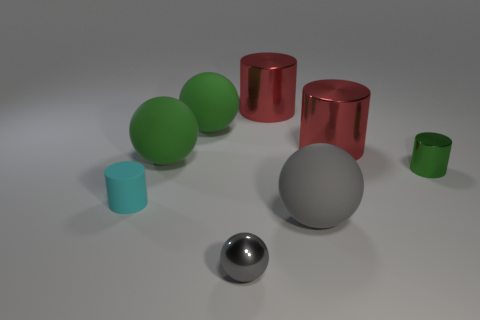How many tiny gray shiny spheres are there?
Your answer should be very brief. 1. How many metallic objects are behind the matte cylinder and in front of the large gray rubber thing?
Your answer should be very brief. 0. What material is the small cyan thing?
Provide a short and direct response. Rubber. Are there any small rubber objects?
Offer a very short reply. Yes. What color is the tiny cylinder behind the matte cylinder?
Keep it short and to the point. Green. What number of big spheres are in front of the tiny thing that is right of the shiny object in front of the big gray object?
Provide a short and direct response. 1. There is a thing that is to the left of the shiny sphere and in front of the small green metal object; what material is it?
Offer a terse response. Rubber. Do the cyan thing and the small green cylinder on the right side of the cyan matte object have the same material?
Ensure brevity in your answer.  No. Are there more red cylinders that are left of the cyan thing than small rubber cylinders that are right of the big gray matte thing?
Your answer should be very brief. No. What shape is the small green shiny thing?
Offer a very short reply. Cylinder. 